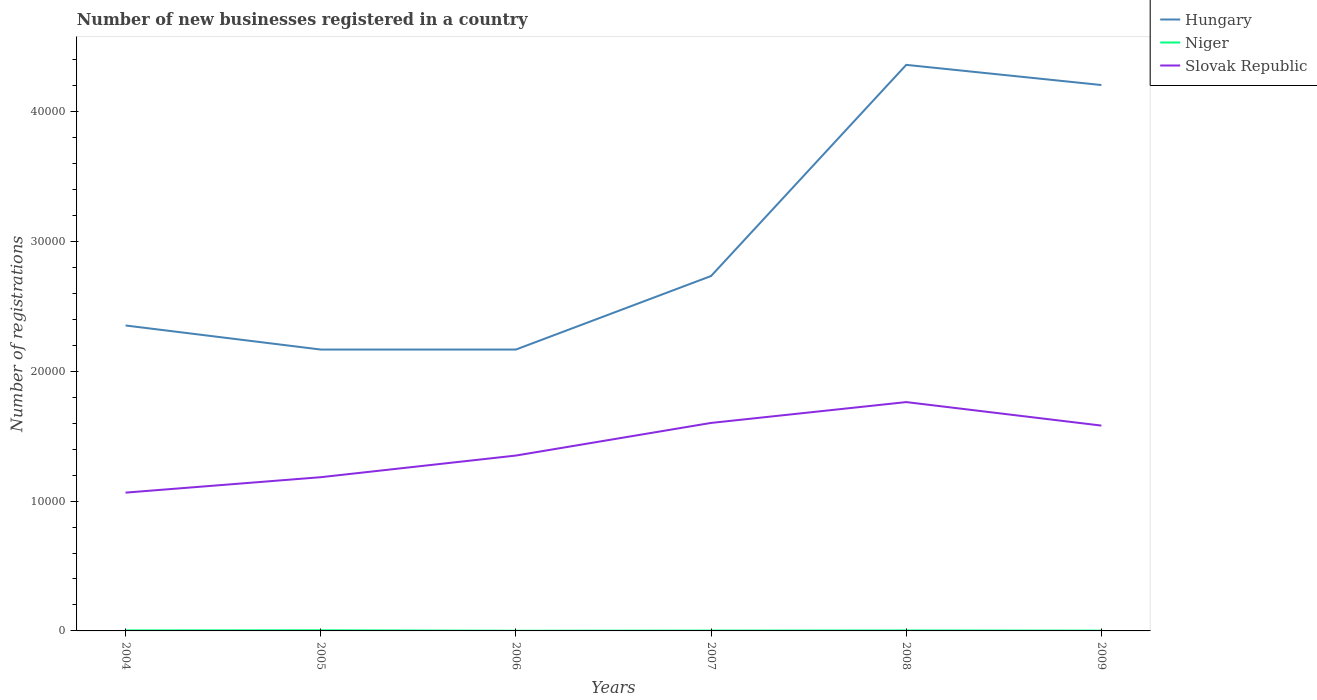How many different coloured lines are there?
Ensure brevity in your answer.  3. In which year was the number of new businesses registered in Hungary maximum?
Your answer should be very brief. 2005. What is the total number of new businesses registered in Slovak Republic in the graph?
Offer a terse response. -4118. What is the difference between the highest and the lowest number of new businesses registered in Hungary?
Your answer should be compact. 2. How many years are there in the graph?
Ensure brevity in your answer.  6. Are the values on the major ticks of Y-axis written in scientific E-notation?
Your response must be concise. No. Does the graph contain any zero values?
Give a very brief answer. No. Where does the legend appear in the graph?
Ensure brevity in your answer.  Top right. How are the legend labels stacked?
Your answer should be compact. Vertical. What is the title of the graph?
Give a very brief answer. Number of new businesses registered in a country. Does "India" appear as one of the legend labels in the graph?
Offer a very short reply. No. What is the label or title of the X-axis?
Your answer should be compact. Years. What is the label or title of the Y-axis?
Your answer should be very brief. Number of registrations. What is the Number of registrations of Hungary in 2004?
Ensure brevity in your answer.  2.35e+04. What is the Number of registrations of Niger in 2004?
Your answer should be compact. 41. What is the Number of registrations in Slovak Republic in 2004?
Your answer should be compact. 1.07e+04. What is the Number of registrations of Hungary in 2005?
Make the answer very short. 2.17e+04. What is the Number of registrations of Niger in 2005?
Provide a short and direct response. 49. What is the Number of registrations of Slovak Republic in 2005?
Offer a very short reply. 1.18e+04. What is the Number of registrations in Hungary in 2006?
Offer a terse response. 2.17e+04. What is the Number of registrations of Niger in 2006?
Offer a terse response. 14. What is the Number of registrations in Slovak Republic in 2006?
Ensure brevity in your answer.  1.35e+04. What is the Number of registrations of Hungary in 2007?
Keep it short and to the point. 2.73e+04. What is the Number of registrations in Slovak Republic in 2007?
Provide a succinct answer. 1.60e+04. What is the Number of registrations in Hungary in 2008?
Make the answer very short. 4.36e+04. What is the Number of registrations of Slovak Republic in 2008?
Give a very brief answer. 1.76e+04. What is the Number of registrations in Hungary in 2009?
Your answer should be compact. 4.20e+04. What is the Number of registrations in Slovak Republic in 2009?
Offer a terse response. 1.58e+04. Across all years, what is the maximum Number of registrations in Hungary?
Your answer should be compact. 4.36e+04. Across all years, what is the maximum Number of registrations of Niger?
Your answer should be compact. 49. Across all years, what is the maximum Number of registrations in Slovak Republic?
Your response must be concise. 1.76e+04. Across all years, what is the minimum Number of registrations of Hungary?
Your response must be concise. 2.17e+04. Across all years, what is the minimum Number of registrations in Niger?
Make the answer very short. 14. Across all years, what is the minimum Number of registrations in Slovak Republic?
Your response must be concise. 1.07e+04. What is the total Number of registrations of Hungary in the graph?
Give a very brief answer. 1.80e+05. What is the total Number of registrations of Niger in the graph?
Keep it short and to the point. 191. What is the total Number of registrations of Slovak Republic in the graph?
Your response must be concise. 8.55e+04. What is the difference between the Number of registrations of Hungary in 2004 and that in 2005?
Offer a terse response. 1854. What is the difference between the Number of registrations of Niger in 2004 and that in 2005?
Your answer should be very brief. -8. What is the difference between the Number of registrations of Slovak Republic in 2004 and that in 2005?
Keep it short and to the point. -1188. What is the difference between the Number of registrations in Hungary in 2004 and that in 2006?
Your response must be concise. 1854. What is the difference between the Number of registrations in Niger in 2004 and that in 2006?
Give a very brief answer. 27. What is the difference between the Number of registrations of Slovak Republic in 2004 and that in 2006?
Ensure brevity in your answer.  -2855. What is the difference between the Number of registrations in Hungary in 2004 and that in 2007?
Keep it short and to the point. -3809. What is the difference between the Number of registrations in Niger in 2004 and that in 2007?
Keep it short and to the point. 14. What is the difference between the Number of registrations of Slovak Republic in 2004 and that in 2007?
Ensure brevity in your answer.  -5368. What is the difference between the Number of registrations of Hungary in 2004 and that in 2008?
Give a very brief answer. -2.01e+04. What is the difference between the Number of registrations of Niger in 2004 and that in 2008?
Provide a succinct answer. 5. What is the difference between the Number of registrations of Slovak Republic in 2004 and that in 2008?
Your answer should be very brief. -6973. What is the difference between the Number of registrations of Hungary in 2004 and that in 2009?
Give a very brief answer. -1.85e+04. What is the difference between the Number of registrations in Niger in 2004 and that in 2009?
Your answer should be very brief. 17. What is the difference between the Number of registrations in Slovak Republic in 2004 and that in 2009?
Provide a short and direct response. -5163. What is the difference between the Number of registrations in Niger in 2005 and that in 2006?
Keep it short and to the point. 35. What is the difference between the Number of registrations in Slovak Republic in 2005 and that in 2006?
Offer a terse response. -1667. What is the difference between the Number of registrations in Hungary in 2005 and that in 2007?
Provide a short and direct response. -5663. What is the difference between the Number of registrations in Niger in 2005 and that in 2007?
Your answer should be compact. 22. What is the difference between the Number of registrations of Slovak Republic in 2005 and that in 2007?
Your answer should be very brief. -4180. What is the difference between the Number of registrations in Hungary in 2005 and that in 2008?
Provide a succinct answer. -2.19e+04. What is the difference between the Number of registrations in Slovak Republic in 2005 and that in 2008?
Offer a very short reply. -5785. What is the difference between the Number of registrations of Hungary in 2005 and that in 2009?
Ensure brevity in your answer.  -2.04e+04. What is the difference between the Number of registrations in Niger in 2005 and that in 2009?
Offer a very short reply. 25. What is the difference between the Number of registrations in Slovak Republic in 2005 and that in 2009?
Provide a short and direct response. -3975. What is the difference between the Number of registrations of Hungary in 2006 and that in 2007?
Make the answer very short. -5663. What is the difference between the Number of registrations of Niger in 2006 and that in 2007?
Provide a succinct answer. -13. What is the difference between the Number of registrations of Slovak Republic in 2006 and that in 2007?
Your response must be concise. -2513. What is the difference between the Number of registrations of Hungary in 2006 and that in 2008?
Your response must be concise. -2.19e+04. What is the difference between the Number of registrations of Slovak Republic in 2006 and that in 2008?
Offer a terse response. -4118. What is the difference between the Number of registrations in Hungary in 2006 and that in 2009?
Make the answer very short. -2.04e+04. What is the difference between the Number of registrations in Slovak Republic in 2006 and that in 2009?
Provide a succinct answer. -2308. What is the difference between the Number of registrations of Hungary in 2007 and that in 2008?
Your response must be concise. -1.63e+04. What is the difference between the Number of registrations in Slovak Republic in 2007 and that in 2008?
Offer a very short reply. -1605. What is the difference between the Number of registrations of Hungary in 2007 and that in 2009?
Your answer should be compact. -1.47e+04. What is the difference between the Number of registrations in Slovak Republic in 2007 and that in 2009?
Provide a short and direct response. 205. What is the difference between the Number of registrations in Hungary in 2008 and that in 2009?
Ensure brevity in your answer.  1552. What is the difference between the Number of registrations in Slovak Republic in 2008 and that in 2009?
Ensure brevity in your answer.  1810. What is the difference between the Number of registrations of Hungary in 2004 and the Number of registrations of Niger in 2005?
Ensure brevity in your answer.  2.35e+04. What is the difference between the Number of registrations of Hungary in 2004 and the Number of registrations of Slovak Republic in 2005?
Make the answer very short. 1.17e+04. What is the difference between the Number of registrations of Niger in 2004 and the Number of registrations of Slovak Republic in 2005?
Your response must be concise. -1.18e+04. What is the difference between the Number of registrations in Hungary in 2004 and the Number of registrations in Niger in 2006?
Provide a succinct answer. 2.35e+04. What is the difference between the Number of registrations of Hungary in 2004 and the Number of registrations of Slovak Republic in 2006?
Offer a terse response. 1.00e+04. What is the difference between the Number of registrations of Niger in 2004 and the Number of registrations of Slovak Republic in 2006?
Your answer should be very brief. -1.35e+04. What is the difference between the Number of registrations in Hungary in 2004 and the Number of registrations in Niger in 2007?
Make the answer very short. 2.35e+04. What is the difference between the Number of registrations in Hungary in 2004 and the Number of registrations in Slovak Republic in 2007?
Your answer should be compact. 7506. What is the difference between the Number of registrations of Niger in 2004 and the Number of registrations of Slovak Republic in 2007?
Your answer should be compact. -1.60e+04. What is the difference between the Number of registrations in Hungary in 2004 and the Number of registrations in Niger in 2008?
Offer a terse response. 2.35e+04. What is the difference between the Number of registrations of Hungary in 2004 and the Number of registrations of Slovak Republic in 2008?
Give a very brief answer. 5901. What is the difference between the Number of registrations in Niger in 2004 and the Number of registrations in Slovak Republic in 2008?
Give a very brief answer. -1.76e+04. What is the difference between the Number of registrations in Hungary in 2004 and the Number of registrations in Niger in 2009?
Keep it short and to the point. 2.35e+04. What is the difference between the Number of registrations of Hungary in 2004 and the Number of registrations of Slovak Republic in 2009?
Offer a very short reply. 7711. What is the difference between the Number of registrations in Niger in 2004 and the Number of registrations in Slovak Republic in 2009?
Your response must be concise. -1.58e+04. What is the difference between the Number of registrations of Hungary in 2005 and the Number of registrations of Niger in 2006?
Your answer should be compact. 2.17e+04. What is the difference between the Number of registrations in Hungary in 2005 and the Number of registrations in Slovak Republic in 2006?
Provide a short and direct response. 8165. What is the difference between the Number of registrations in Niger in 2005 and the Number of registrations in Slovak Republic in 2006?
Offer a very short reply. -1.35e+04. What is the difference between the Number of registrations in Hungary in 2005 and the Number of registrations in Niger in 2007?
Give a very brief answer. 2.16e+04. What is the difference between the Number of registrations of Hungary in 2005 and the Number of registrations of Slovak Republic in 2007?
Offer a very short reply. 5652. What is the difference between the Number of registrations in Niger in 2005 and the Number of registrations in Slovak Republic in 2007?
Keep it short and to the point. -1.60e+04. What is the difference between the Number of registrations in Hungary in 2005 and the Number of registrations in Niger in 2008?
Your response must be concise. 2.16e+04. What is the difference between the Number of registrations in Hungary in 2005 and the Number of registrations in Slovak Republic in 2008?
Give a very brief answer. 4047. What is the difference between the Number of registrations of Niger in 2005 and the Number of registrations of Slovak Republic in 2008?
Your response must be concise. -1.76e+04. What is the difference between the Number of registrations of Hungary in 2005 and the Number of registrations of Niger in 2009?
Your response must be concise. 2.16e+04. What is the difference between the Number of registrations of Hungary in 2005 and the Number of registrations of Slovak Republic in 2009?
Your answer should be compact. 5857. What is the difference between the Number of registrations of Niger in 2005 and the Number of registrations of Slovak Republic in 2009?
Make the answer very short. -1.58e+04. What is the difference between the Number of registrations in Hungary in 2006 and the Number of registrations in Niger in 2007?
Give a very brief answer. 2.16e+04. What is the difference between the Number of registrations in Hungary in 2006 and the Number of registrations in Slovak Republic in 2007?
Your response must be concise. 5652. What is the difference between the Number of registrations in Niger in 2006 and the Number of registrations in Slovak Republic in 2007?
Provide a short and direct response. -1.60e+04. What is the difference between the Number of registrations in Hungary in 2006 and the Number of registrations in Niger in 2008?
Ensure brevity in your answer.  2.16e+04. What is the difference between the Number of registrations of Hungary in 2006 and the Number of registrations of Slovak Republic in 2008?
Your answer should be very brief. 4047. What is the difference between the Number of registrations in Niger in 2006 and the Number of registrations in Slovak Republic in 2008?
Provide a succinct answer. -1.76e+04. What is the difference between the Number of registrations of Hungary in 2006 and the Number of registrations of Niger in 2009?
Your answer should be very brief. 2.16e+04. What is the difference between the Number of registrations of Hungary in 2006 and the Number of registrations of Slovak Republic in 2009?
Provide a succinct answer. 5857. What is the difference between the Number of registrations of Niger in 2006 and the Number of registrations of Slovak Republic in 2009?
Give a very brief answer. -1.58e+04. What is the difference between the Number of registrations of Hungary in 2007 and the Number of registrations of Niger in 2008?
Ensure brevity in your answer.  2.73e+04. What is the difference between the Number of registrations of Hungary in 2007 and the Number of registrations of Slovak Republic in 2008?
Offer a terse response. 9710. What is the difference between the Number of registrations of Niger in 2007 and the Number of registrations of Slovak Republic in 2008?
Provide a succinct answer. -1.76e+04. What is the difference between the Number of registrations of Hungary in 2007 and the Number of registrations of Niger in 2009?
Your answer should be very brief. 2.73e+04. What is the difference between the Number of registrations in Hungary in 2007 and the Number of registrations in Slovak Republic in 2009?
Give a very brief answer. 1.15e+04. What is the difference between the Number of registrations in Niger in 2007 and the Number of registrations in Slovak Republic in 2009?
Make the answer very short. -1.58e+04. What is the difference between the Number of registrations of Hungary in 2008 and the Number of registrations of Niger in 2009?
Give a very brief answer. 4.36e+04. What is the difference between the Number of registrations in Hungary in 2008 and the Number of registrations in Slovak Republic in 2009?
Provide a short and direct response. 2.78e+04. What is the difference between the Number of registrations of Niger in 2008 and the Number of registrations of Slovak Republic in 2009?
Provide a short and direct response. -1.58e+04. What is the average Number of registrations in Hungary per year?
Your answer should be very brief. 3.00e+04. What is the average Number of registrations in Niger per year?
Provide a short and direct response. 31.83. What is the average Number of registrations in Slovak Republic per year?
Your answer should be very brief. 1.42e+04. In the year 2004, what is the difference between the Number of registrations in Hungary and Number of registrations in Niger?
Make the answer very short. 2.35e+04. In the year 2004, what is the difference between the Number of registrations of Hungary and Number of registrations of Slovak Republic?
Your answer should be very brief. 1.29e+04. In the year 2004, what is the difference between the Number of registrations in Niger and Number of registrations in Slovak Republic?
Keep it short and to the point. -1.06e+04. In the year 2005, what is the difference between the Number of registrations of Hungary and Number of registrations of Niger?
Your response must be concise. 2.16e+04. In the year 2005, what is the difference between the Number of registrations in Hungary and Number of registrations in Slovak Republic?
Offer a terse response. 9832. In the year 2005, what is the difference between the Number of registrations of Niger and Number of registrations of Slovak Republic?
Your response must be concise. -1.18e+04. In the year 2006, what is the difference between the Number of registrations in Hungary and Number of registrations in Niger?
Keep it short and to the point. 2.17e+04. In the year 2006, what is the difference between the Number of registrations of Hungary and Number of registrations of Slovak Republic?
Provide a short and direct response. 8165. In the year 2006, what is the difference between the Number of registrations of Niger and Number of registrations of Slovak Republic?
Provide a succinct answer. -1.35e+04. In the year 2007, what is the difference between the Number of registrations of Hungary and Number of registrations of Niger?
Your response must be concise. 2.73e+04. In the year 2007, what is the difference between the Number of registrations in Hungary and Number of registrations in Slovak Republic?
Offer a terse response. 1.13e+04. In the year 2007, what is the difference between the Number of registrations of Niger and Number of registrations of Slovak Republic?
Make the answer very short. -1.60e+04. In the year 2008, what is the difference between the Number of registrations of Hungary and Number of registrations of Niger?
Keep it short and to the point. 4.36e+04. In the year 2008, what is the difference between the Number of registrations in Hungary and Number of registrations in Slovak Republic?
Your response must be concise. 2.60e+04. In the year 2008, what is the difference between the Number of registrations in Niger and Number of registrations in Slovak Republic?
Your answer should be very brief. -1.76e+04. In the year 2009, what is the difference between the Number of registrations of Hungary and Number of registrations of Niger?
Give a very brief answer. 4.20e+04. In the year 2009, what is the difference between the Number of registrations of Hungary and Number of registrations of Slovak Republic?
Keep it short and to the point. 2.62e+04. In the year 2009, what is the difference between the Number of registrations in Niger and Number of registrations in Slovak Republic?
Offer a terse response. -1.58e+04. What is the ratio of the Number of registrations in Hungary in 2004 to that in 2005?
Keep it short and to the point. 1.09. What is the ratio of the Number of registrations in Niger in 2004 to that in 2005?
Provide a succinct answer. 0.84. What is the ratio of the Number of registrations of Slovak Republic in 2004 to that in 2005?
Ensure brevity in your answer.  0.9. What is the ratio of the Number of registrations in Hungary in 2004 to that in 2006?
Provide a succinct answer. 1.09. What is the ratio of the Number of registrations of Niger in 2004 to that in 2006?
Provide a succinct answer. 2.93. What is the ratio of the Number of registrations in Slovak Republic in 2004 to that in 2006?
Your response must be concise. 0.79. What is the ratio of the Number of registrations in Hungary in 2004 to that in 2007?
Your answer should be compact. 0.86. What is the ratio of the Number of registrations in Niger in 2004 to that in 2007?
Give a very brief answer. 1.52. What is the ratio of the Number of registrations in Slovak Republic in 2004 to that in 2007?
Your answer should be very brief. 0.66. What is the ratio of the Number of registrations in Hungary in 2004 to that in 2008?
Offer a terse response. 0.54. What is the ratio of the Number of registrations of Niger in 2004 to that in 2008?
Your answer should be very brief. 1.14. What is the ratio of the Number of registrations of Slovak Republic in 2004 to that in 2008?
Make the answer very short. 0.6. What is the ratio of the Number of registrations of Hungary in 2004 to that in 2009?
Ensure brevity in your answer.  0.56. What is the ratio of the Number of registrations in Niger in 2004 to that in 2009?
Make the answer very short. 1.71. What is the ratio of the Number of registrations in Slovak Republic in 2004 to that in 2009?
Keep it short and to the point. 0.67. What is the ratio of the Number of registrations in Hungary in 2005 to that in 2006?
Offer a very short reply. 1. What is the ratio of the Number of registrations in Slovak Republic in 2005 to that in 2006?
Your answer should be very brief. 0.88. What is the ratio of the Number of registrations in Hungary in 2005 to that in 2007?
Offer a very short reply. 0.79. What is the ratio of the Number of registrations of Niger in 2005 to that in 2007?
Make the answer very short. 1.81. What is the ratio of the Number of registrations in Slovak Republic in 2005 to that in 2007?
Your answer should be very brief. 0.74. What is the ratio of the Number of registrations in Hungary in 2005 to that in 2008?
Keep it short and to the point. 0.5. What is the ratio of the Number of registrations of Niger in 2005 to that in 2008?
Offer a very short reply. 1.36. What is the ratio of the Number of registrations of Slovak Republic in 2005 to that in 2008?
Keep it short and to the point. 0.67. What is the ratio of the Number of registrations in Hungary in 2005 to that in 2009?
Your answer should be very brief. 0.52. What is the ratio of the Number of registrations of Niger in 2005 to that in 2009?
Give a very brief answer. 2.04. What is the ratio of the Number of registrations of Slovak Republic in 2005 to that in 2009?
Provide a succinct answer. 0.75. What is the ratio of the Number of registrations of Hungary in 2006 to that in 2007?
Offer a very short reply. 0.79. What is the ratio of the Number of registrations in Niger in 2006 to that in 2007?
Provide a short and direct response. 0.52. What is the ratio of the Number of registrations of Slovak Republic in 2006 to that in 2007?
Your response must be concise. 0.84. What is the ratio of the Number of registrations in Hungary in 2006 to that in 2008?
Provide a succinct answer. 0.5. What is the ratio of the Number of registrations in Niger in 2006 to that in 2008?
Your response must be concise. 0.39. What is the ratio of the Number of registrations in Slovak Republic in 2006 to that in 2008?
Make the answer very short. 0.77. What is the ratio of the Number of registrations of Hungary in 2006 to that in 2009?
Provide a short and direct response. 0.52. What is the ratio of the Number of registrations in Niger in 2006 to that in 2009?
Your response must be concise. 0.58. What is the ratio of the Number of registrations in Slovak Republic in 2006 to that in 2009?
Your response must be concise. 0.85. What is the ratio of the Number of registrations of Hungary in 2007 to that in 2008?
Your answer should be compact. 0.63. What is the ratio of the Number of registrations in Niger in 2007 to that in 2008?
Your response must be concise. 0.75. What is the ratio of the Number of registrations in Slovak Republic in 2007 to that in 2008?
Your answer should be very brief. 0.91. What is the ratio of the Number of registrations in Hungary in 2007 to that in 2009?
Give a very brief answer. 0.65. What is the ratio of the Number of registrations of Niger in 2007 to that in 2009?
Give a very brief answer. 1.12. What is the ratio of the Number of registrations of Slovak Republic in 2007 to that in 2009?
Your response must be concise. 1.01. What is the ratio of the Number of registrations of Hungary in 2008 to that in 2009?
Provide a succinct answer. 1.04. What is the ratio of the Number of registrations in Niger in 2008 to that in 2009?
Provide a short and direct response. 1.5. What is the ratio of the Number of registrations of Slovak Republic in 2008 to that in 2009?
Provide a short and direct response. 1.11. What is the difference between the highest and the second highest Number of registrations of Hungary?
Provide a succinct answer. 1552. What is the difference between the highest and the second highest Number of registrations in Slovak Republic?
Provide a succinct answer. 1605. What is the difference between the highest and the lowest Number of registrations in Hungary?
Your answer should be compact. 2.19e+04. What is the difference between the highest and the lowest Number of registrations in Niger?
Offer a very short reply. 35. What is the difference between the highest and the lowest Number of registrations of Slovak Republic?
Ensure brevity in your answer.  6973. 